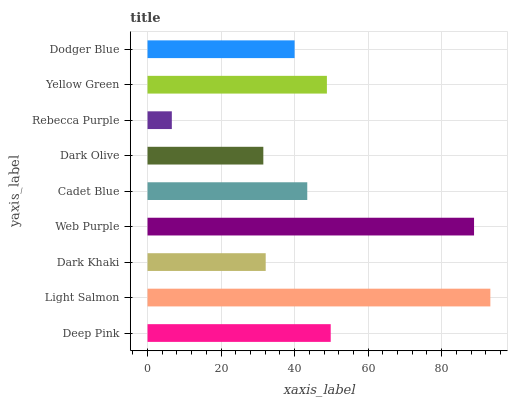Is Rebecca Purple the minimum?
Answer yes or no. Yes. Is Light Salmon the maximum?
Answer yes or no. Yes. Is Dark Khaki the minimum?
Answer yes or no. No. Is Dark Khaki the maximum?
Answer yes or no. No. Is Light Salmon greater than Dark Khaki?
Answer yes or no. Yes. Is Dark Khaki less than Light Salmon?
Answer yes or no. Yes. Is Dark Khaki greater than Light Salmon?
Answer yes or no. No. Is Light Salmon less than Dark Khaki?
Answer yes or no. No. Is Cadet Blue the high median?
Answer yes or no. Yes. Is Cadet Blue the low median?
Answer yes or no. Yes. Is Light Salmon the high median?
Answer yes or no. No. Is Yellow Green the low median?
Answer yes or no. No. 